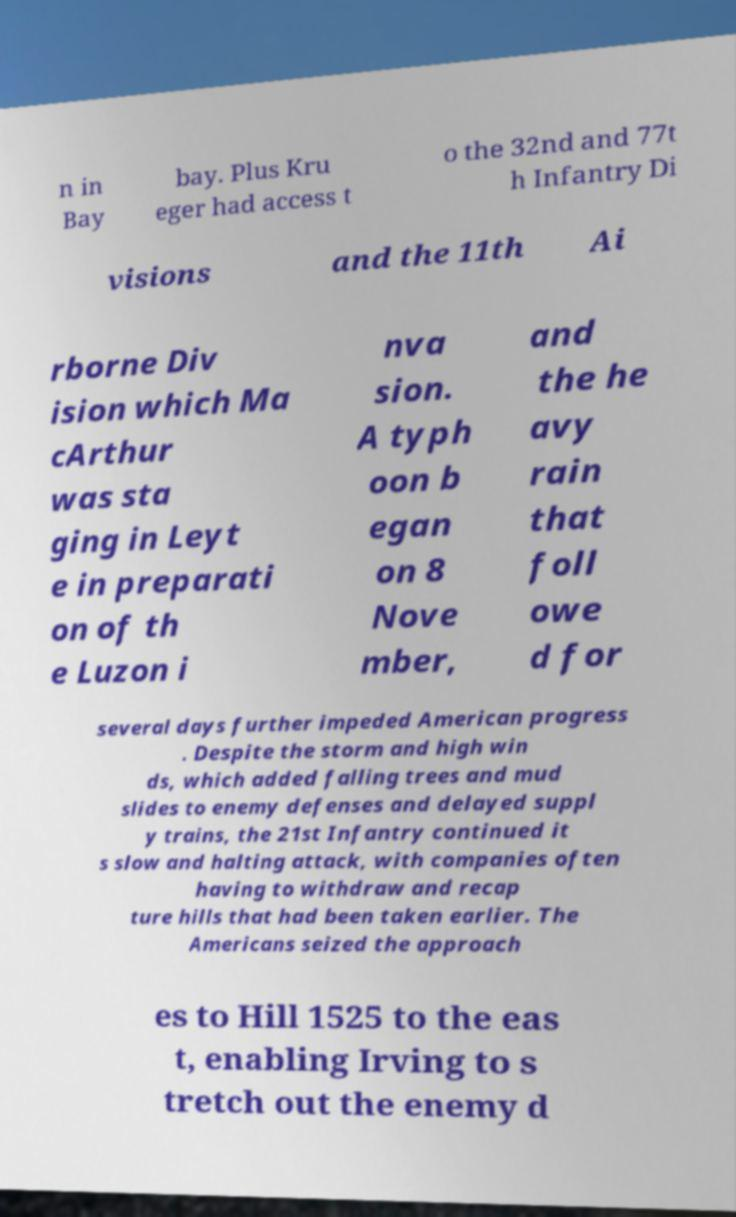Can you read and provide the text displayed in the image?This photo seems to have some interesting text. Can you extract and type it out for me? n in Bay bay. Plus Kru eger had access t o the 32nd and 77t h Infantry Di visions and the 11th Ai rborne Div ision which Ma cArthur was sta ging in Leyt e in preparati on of th e Luzon i nva sion. A typh oon b egan on 8 Nove mber, and the he avy rain that foll owe d for several days further impeded American progress . Despite the storm and high win ds, which added falling trees and mud slides to enemy defenses and delayed suppl y trains, the 21st Infantry continued it s slow and halting attack, with companies often having to withdraw and recap ture hills that had been taken earlier. The Americans seized the approach es to Hill 1525 to the eas t, enabling Irving to s tretch out the enemy d 